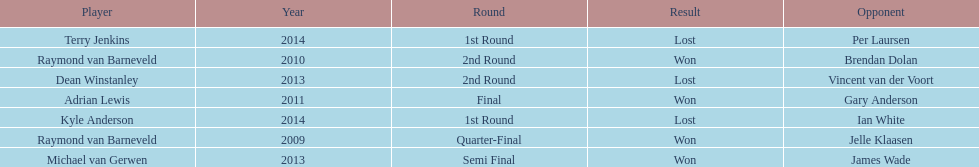What was the names of all the players? Raymond van Barneveld, Raymond van Barneveld, Adrian Lewis, Dean Winstanley, Michael van Gerwen, Terry Jenkins, Kyle Anderson. What years were the championship offered? 2009, 2010, 2011, 2013, 2013, 2014, 2014. Of these, who played in 2011? Adrian Lewis. 